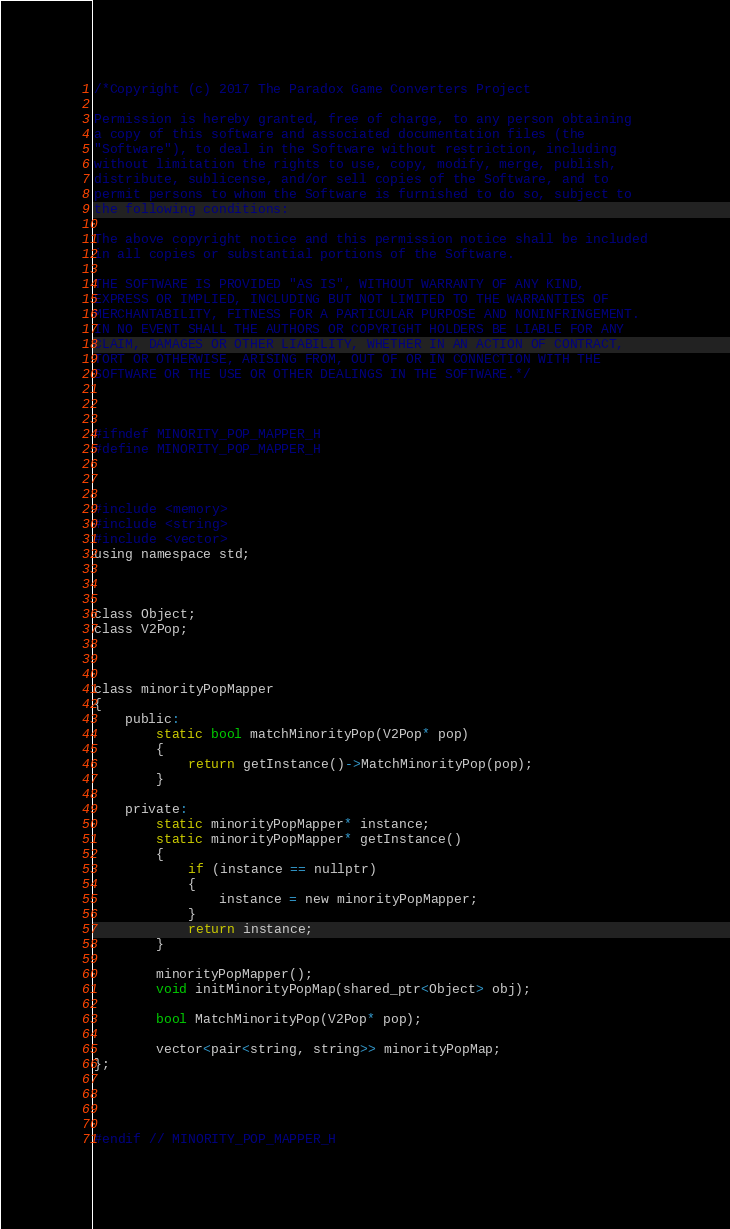<code> <loc_0><loc_0><loc_500><loc_500><_C_>/*Copyright (c) 2017 The Paradox Game Converters Project

Permission is hereby granted, free of charge, to any person obtaining
a copy of this software and associated documentation files (the
"Software"), to deal in the Software without restriction, including
without limitation the rights to use, copy, modify, merge, publish,
distribute, sublicense, and/or sell copies of the Software, and to
permit persons to whom the Software is furnished to do so, subject to
the following conditions:

The above copyright notice and this permission notice shall be included
in all copies or substantial portions of the Software.

THE SOFTWARE IS PROVIDED "AS IS", WITHOUT WARRANTY OF ANY KIND,
EXPRESS OR IMPLIED, INCLUDING BUT NOT LIMITED TO THE WARRANTIES OF
MERCHANTABILITY, FITNESS FOR A PARTICULAR PURPOSE AND NONINFRINGEMENT.
IN NO EVENT SHALL THE AUTHORS OR COPYRIGHT HOLDERS BE LIABLE FOR ANY
CLAIM, DAMAGES OR OTHER LIABILITY, WHETHER IN AN ACTION OF CONTRACT,
TORT OR OTHERWISE, ARISING FROM, OUT OF OR IN CONNECTION WITH THE
SOFTWARE OR THE USE OR OTHER DEALINGS IN THE SOFTWARE.*/



#ifndef MINORITY_POP_MAPPER_H
#define MINORITY_POP_MAPPER_H



#include <memory>
#include <string>
#include <vector>
using namespace std;



class Object;
class V2Pop;



class minorityPopMapper
{
	public:
		static bool matchMinorityPop(V2Pop* pop)
		{
			return getInstance()->MatchMinorityPop(pop);
		}

	private:
		static minorityPopMapper* instance;
		static minorityPopMapper* getInstance()
		{
			if (instance == nullptr)
			{
				instance = new minorityPopMapper;
			}
			return instance;
		}

		minorityPopMapper();
		void initMinorityPopMap(shared_ptr<Object> obj);

		bool MatchMinorityPop(V2Pop* pop);

		vector<pair<string, string>> minorityPopMap;
};




#endif // MINORITY_POP_MAPPER_H
</code> 